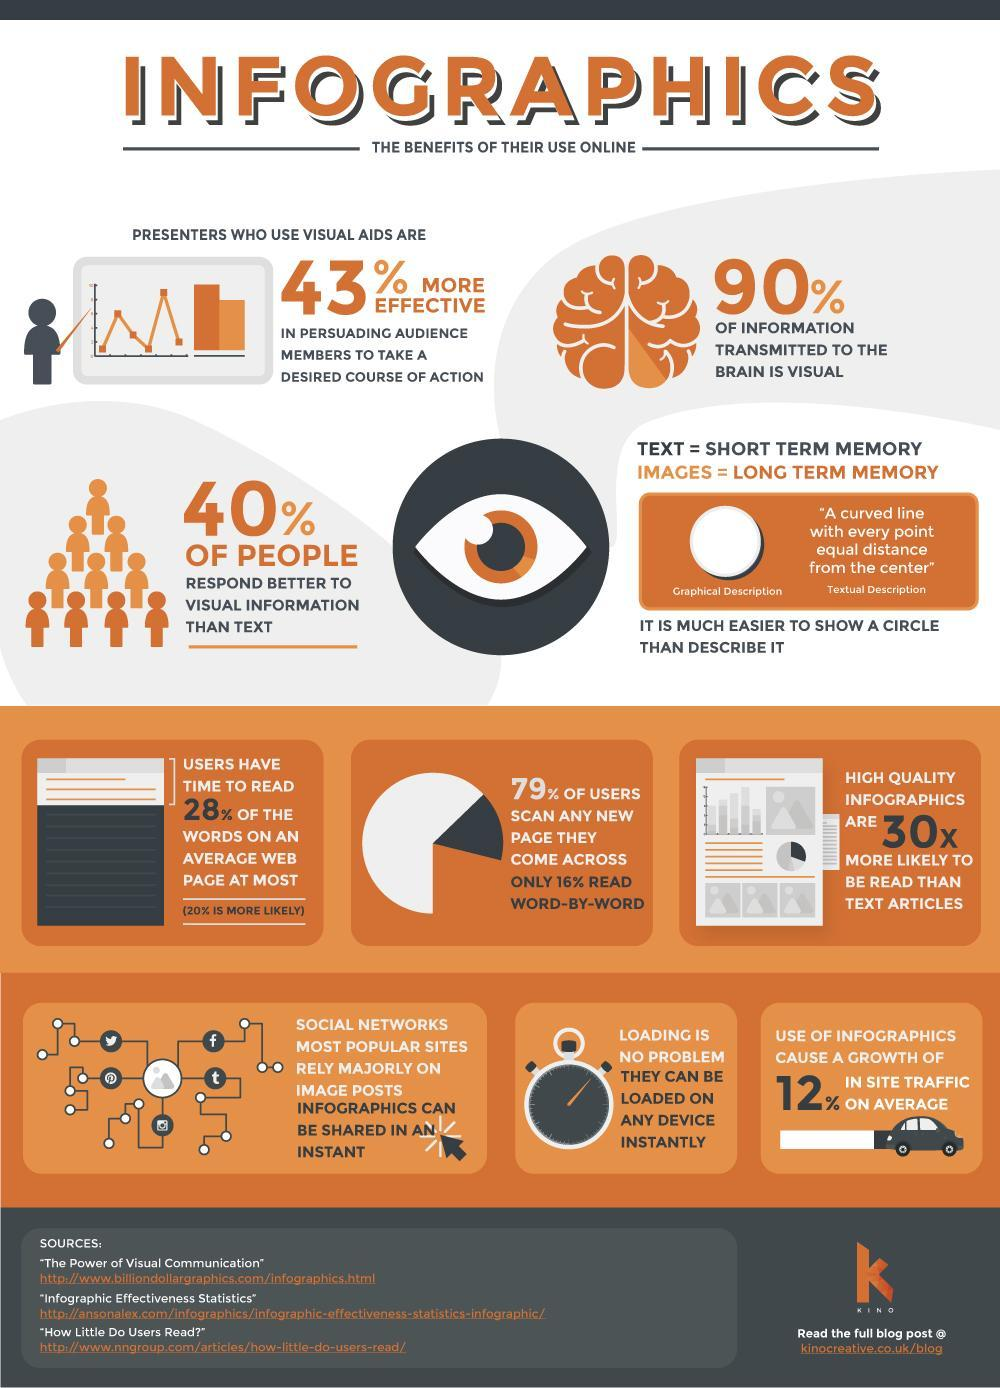How many sources are listed?
Answer the question with a short phrase. 3 Which one is more preferred- high quality infographics or text articles? HIGH QUALITY INFOGRAPHICS 